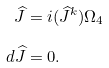<formula> <loc_0><loc_0><loc_500><loc_500>\widehat { J } & = i ( \widehat { J } ^ { k } ) \Omega _ { 4 } \\ d \widehat { J } & = 0 .</formula> 